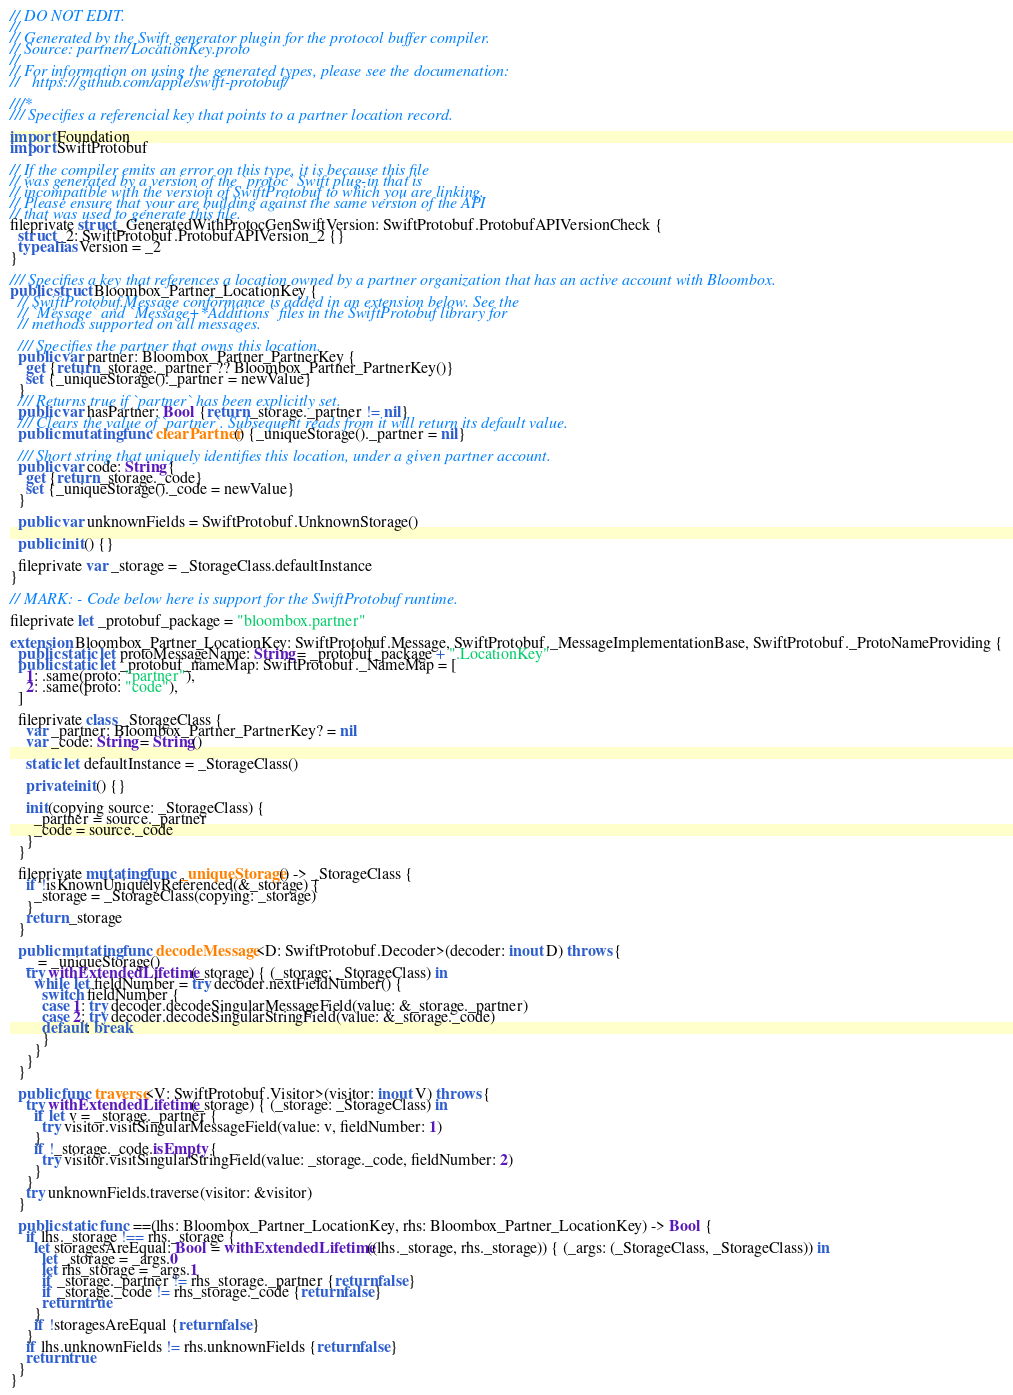<code> <loc_0><loc_0><loc_500><loc_500><_Swift_>// DO NOT EDIT.
//
// Generated by the Swift generator plugin for the protocol buffer compiler.
// Source: partner/LocationKey.proto
//
// For information on using the generated types, please see the documenation:
//   https://github.com/apple/swift-protobuf/

///*
/// Specifies a referencial key that points to a partner location record.

import Foundation
import SwiftProtobuf

// If the compiler emits an error on this type, it is because this file
// was generated by a version of the `protoc` Swift plug-in that is
// incompatible with the version of SwiftProtobuf to which you are linking.
// Please ensure that your are building against the same version of the API
// that was used to generate this file.
fileprivate struct _GeneratedWithProtocGenSwiftVersion: SwiftProtobuf.ProtobufAPIVersionCheck {
  struct _2: SwiftProtobuf.ProtobufAPIVersion_2 {}
  typealias Version = _2
}

/// Specifies a key that references a location owned by a partner organization that has an active account with Bloombox.
public struct Bloombox_Partner_LocationKey {
  // SwiftProtobuf.Message conformance is added in an extension below. See the
  // `Message` and `Message+*Additions` files in the SwiftProtobuf library for
  // methods supported on all messages.

  /// Specifies the partner that owns this location.
  public var partner: Bloombox_Partner_PartnerKey {
    get {return _storage._partner ?? Bloombox_Partner_PartnerKey()}
    set {_uniqueStorage()._partner = newValue}
  }
  /// Returns true if `partner` has been explicitly set.
  public var hasPartner: Bool {return _storage._partner != nil}
  /// Clears the value of `partner`. Subsequent reads from it will return its default value.
  public mutating func clearPartner() {_uniqueStorage()._partner = nil}

  /// Short string that uniquely identifies this location, under a given partner account.
  public var code: String {
    get {return _storage._code}
    set {_uniqueStorage()._code = newValue}
  }

  public var unknownFields = SwiftProtobuf.UnknownStorage()

  public init() {}

  fileprivate var _storage = _StorageClass.defaultInstance
}

// MARK: - Code below here is support for the SwiftProtobuf runtime.

fileprivate let _protobuf_package = "bloombox.partner"

extension Bloombox_Partner_LocationKey: SwiftProtobuf.Message, SwiftProtobuf._MessageImplementationBase, SwiftProtobuf._ProtoNameProviding {
  public static let protoMessageName: String = _protobuf_package + ".LocationKey"
  public static let _protobuf_nameMap: SwiftProtobuf._NameMap = [
    1: .same(proto: "partner"),
    2: .same(proto: "code"),
  ]

  fileprivate class _StorageClass {
    var _partner: Bloombox_Partner_PartnerKey? = nil
    var _code: String = String()

    static let defaultInstance = _StorageClass()

    private init() {}

    init(copying source: _StorageClass) {
      _partner = source._partner
      _code = source._code
    }
  }

  fileprivate mutating func _uniqueStorage() -> _StorageClass {
    if !isKnownUniquelyReferenced(&_storage) {
      _storage = _StorageClass(copying: _storage)
    }
    return _storage
  }

  public mutating func decodeMessage<D: SwiftProtobuf.Decoder>(decoder: inout D) throws {
    _ = _uniqueStorage()
    try withExtendedLifetime(_storage) { (_storage: _StorageClass) in
      while let fieldNumber = try decoder.nextFieldNumber() {
        switch fieldNumber {
        case 1: try decoder.decodeSingularMessageField(value: &_storage._partner)
        case 2: try decoder.decodeSingularStringField(value: &_storage._code)
        default: break
        }
      }
    }
  }

  public func traverse<V: SwiftProtobuf.Visitor>(visitor: inout V) throws {
    try withExtendedLifetime(_storage) { (_storage: _StorageClass) in
      if let v = _storage._partner {
        try visitor.visitSingularMessageField(value: v, fieldNumber: 1)
      }
      if !_storage._code.isEmpty {
        try visitor.visitSingularStringField(value: _storage._code, fieldNumber: 2)
      }
    }
    try unknownFields.traverse(visitor: &visitor)
  }

  public static func ==(lhs: Bloombox_Partner_LocationKey, rhs: Bloombox_Partner_LocationKey) -> Bool {
    if lhs._storage !== rhs._storage {
      let storagesAreEqual: Bool = withExtendedLifetime((lhs._storage, rhs._storage)) { (_args: (_StorageClass, _StorageClass)) in
        let _storage = _args.0
        let rhs_storage = _args.1
        if _storage._partner != rhs_storage._partner {return false}
        if _storage._code != rhs_storage._code {return false}
        return true
      }
      if !storagesAreEqual {return false}
    }
    if lhs.unknownFields != rhs.unknownFields {return false}
    return true
  }
}
</code> 